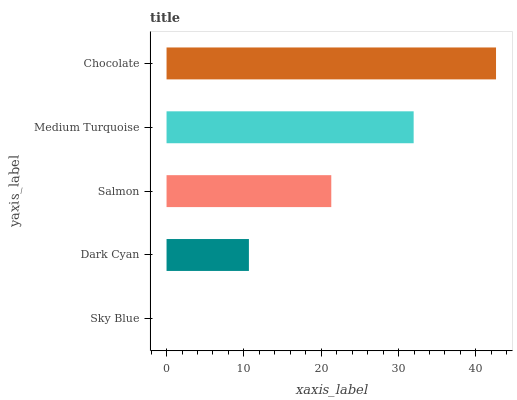Is Sky Blue the minimum?
Answer yes or no. Yes. Is Chocolate the maximum?
Answer yes or no. Yes. Is Dark Cyan the minimum?
Answer yes or no. No. Is Dark Cyan the maximum?
Answer yes or no. No. Is Dark Cyan greater than Sky Blue?
Answer yes or no. Yes. Is Sky Blue less than Dark Cyan?
Answer yes or no. Yes. Is Sky Blue greater than Dark Cyan?
Answer yes or no. No. Is Dark Cyan less than Sky Blue?
Answer yes or no. No. Is Salmon the high median?
Answer yes or no. Yes. Is Salmon the low median?
Answer yes or no. Yes. Is Sky Blue the high median?
Answer yes or no. No. Is Dark Cyan the low median?
Answer yes or no. No. 